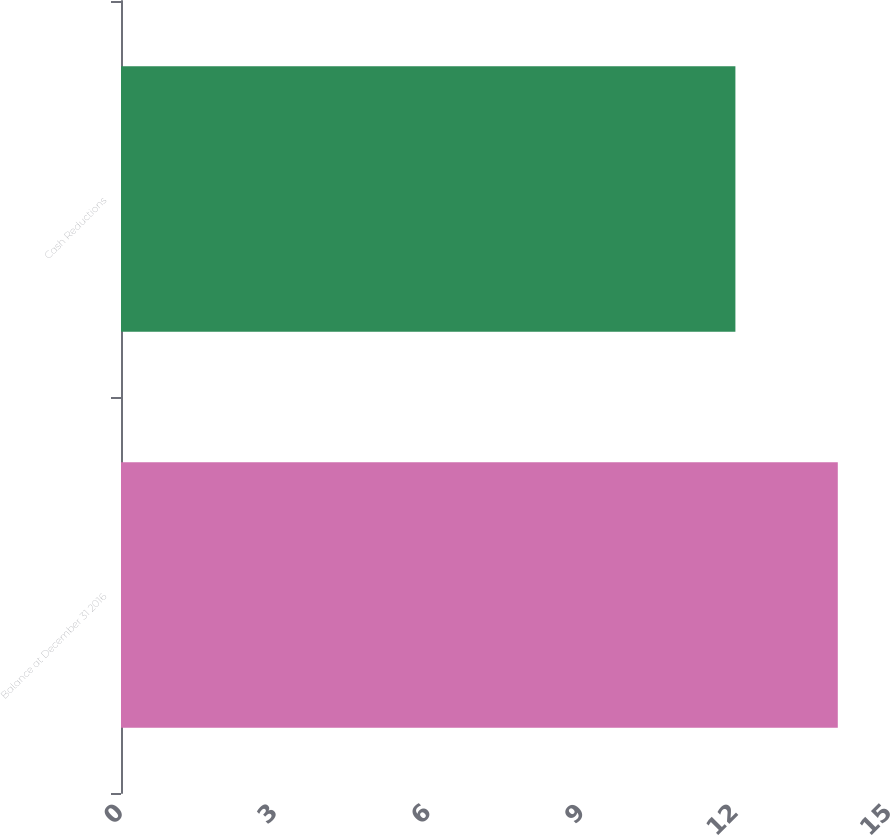Convert chart. <chart><loc_0><loc_0><loc_500><loc_500><bar_chart><fcel>Balance at December 31 2016<fcel>Cash Reductions<nl><fcel>14<fcel>12<nl></chart> 